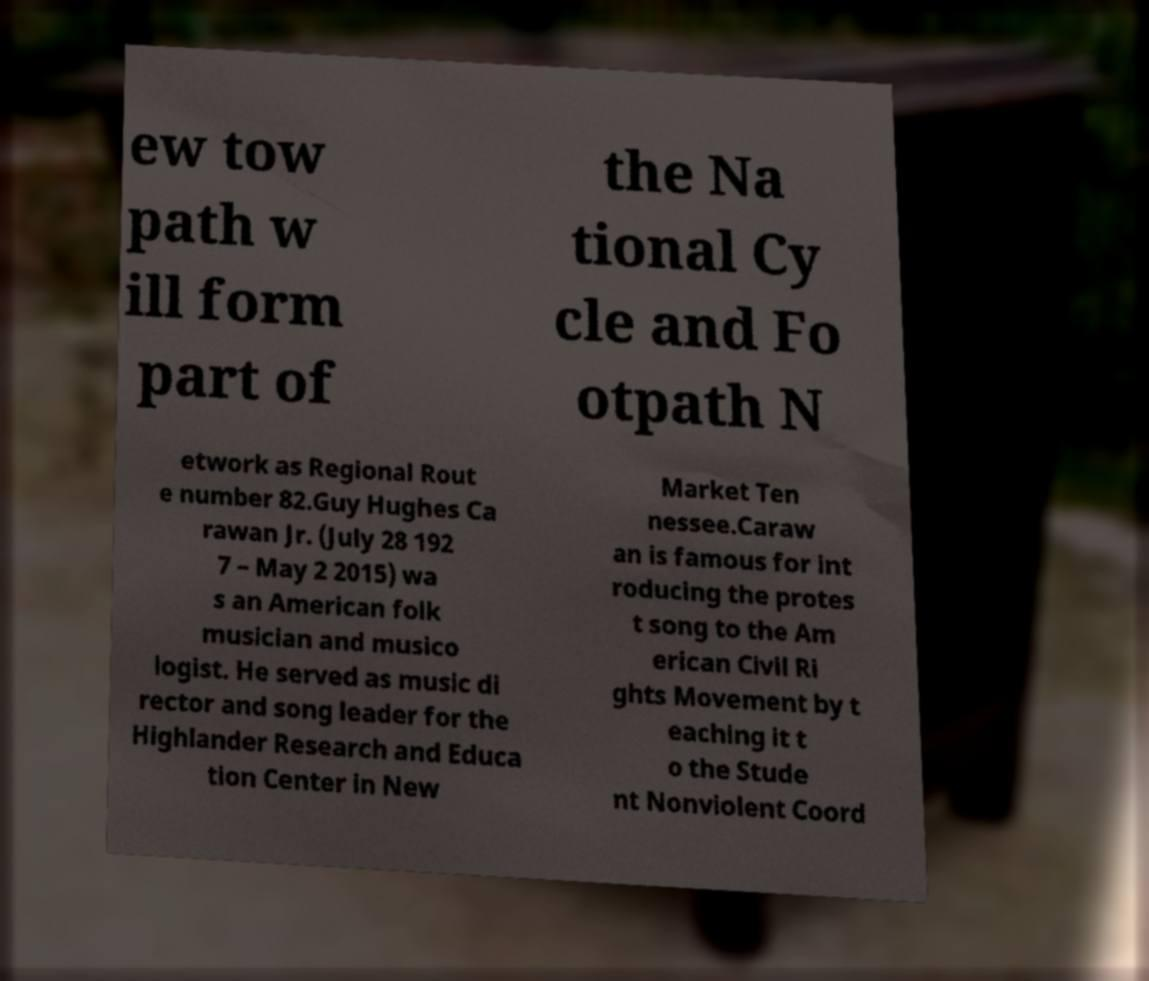There's text embedded in this image that I need extracted. Can you transcribe it verbatim? ew tow path w ill form part of the Na tional Cy cle and Fo otpath N etwork as Regional Rout e number 82.Guy Hughes Ca rawan Jr. (July 28 192 7 – May 2 2015) wa s an American folk musician and musico logist. He served as music di rector and song leader for the Highlander Research and Educa tion Center in New Market Ten nessee.Caraw an is famous for int roducing the protes t song to the Am erican Civil Ri ghts Movement by t eaching it t o the Stude nt Nonviolent Coord 